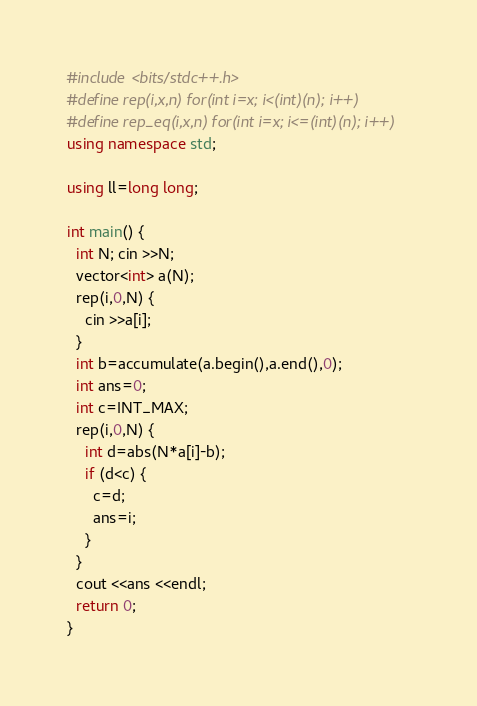<code> <loc_0><loc_0><loc_500><loc_500><_C++_>#include <bits/stdc++.h>
#define rep(i,x,n) for(int i=x; i<(int)(n); i++)
#define rep_eq(i,x,n) for(int i=x; i<=(int)(n); i++)
using namespace std;

using ll=long long;

int main() {
  int N; cin >>N;
  vector<int> a(N);
  rep(i,0,N) {
    cin >>a[i];
  }
  int b=accumulate(a.begin(),a.end(),0);
  int ans=0;
  int c=INT_MAX;
  rep(i,0,N) {
    int d=abs(N*a[i]-b);
    if (d<c) {
      c=d;
      ans=i;
    }
  }
  cout <<ans <<endl;
  return 0;
}
</code> 